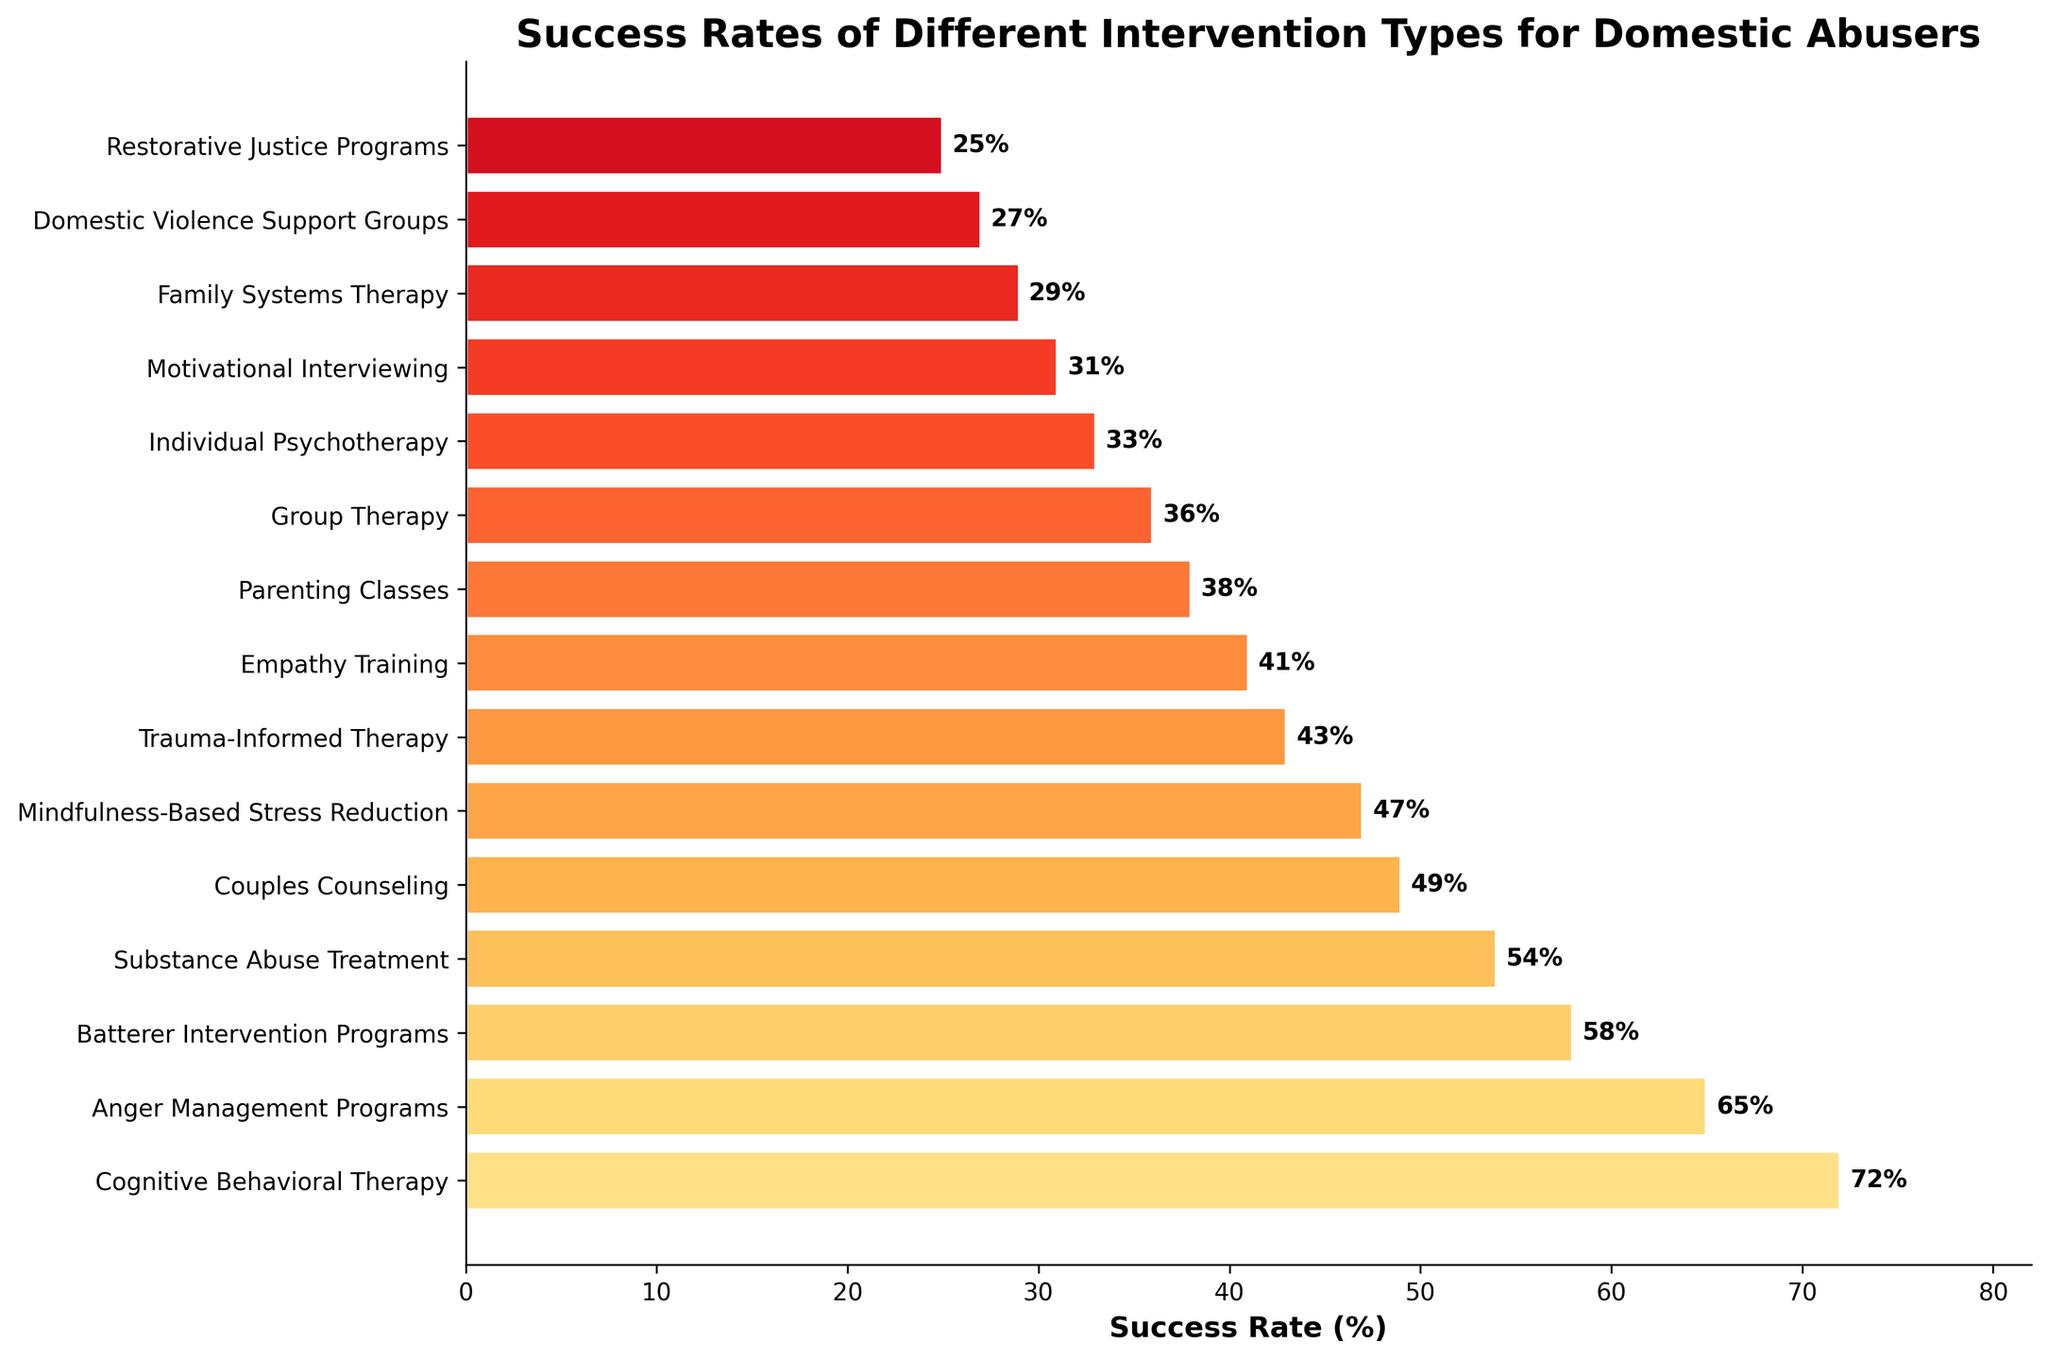Which intervention type has the highest success rate? By looking at the top bar in the bar chart, the intervention type with the highest success rate is displayed.
Answer: Cognitive Behavioral Therapy Which intervention type has the lowest success rate? By looking at the bottom bar in the bar chart, the intervention type with the lowest success rate is displayed.
Answer: Restorative Justice Programs What is the difference in success rates between Anger Management Programs and Batterer Intervention Programs? From the figure, locate the bars corresponding to Anger Management Programs and Batterer Intervention Programs. Subtract the success rate of Batterer Intervention Programs (58%) from Anger Management Programs (65%).
Answer: 7% Which interventions have a success rate above 50%? Identify and list the bars with success rates above 50% from the figure. These are interventions with success rates above the midpoint line.
Answer: Cognitive Behavioral Therapy, Anger Management Programs, Batterer Intervention Programs What is the average success rate of Cognitive Behavioral Therapy, Anger Management Programs, and Batterer Intervention Programs? Add the success rates of Cognitive Behavioral Therapy (72%), Anger Management Programs (65%), and Batterer Intervention Programs (58%) and divide by 3. (72 + 65 + 58) / 3 = 65%
Answer: 65% How much higher is the success rate of Cognitive Behavioral Therapy compared to Individual Psychotherapy? Find the success rates for Cognitive Behavioral Therapy (72%) and Individual Psychotherapy (33%), then subtract the latter from the former.
Answer: 39% Which two intervention types have the closest success rates? Locate bars that are visually close in height and confirm their values. Couples Counseling (49%) and Mindfulness-Based Stress Reduction (47%) have close success rates with a minimal difference.
Answer: Couples Counseling and Mindfulness-Based Stress Reduction What is the median success rate of all the interventions? Order the success rates and find the middle value. With an odd number of interventions (15), the median is the 8th value when ordered. The ordered success rates are: 25, 27, 29, 31, 33, 36, 38, 41, 43, 47, 49, 54, 58, 65, 72. The median is 41.
Answer: 41% Is the success rate of Parenting Classes higher than Mindfulness-Based Stress Reduction? By comparing the heights of the corresponding bars, Parenting Classes (38%) is lower than Mindfulness-Based Stress Reduction (47%).
Answer: No What is the sum of the success rates of Trauma-Informed Therapy, Empathy Training, and Domestic Violence Support Groups? Add the success rates of Trauma-Informed Therapy (43%), Empathy Training (41%), and Domestic Violence Support Groups (27%) together. (43 + 41 + 27) = 111%
Answer: 111% 